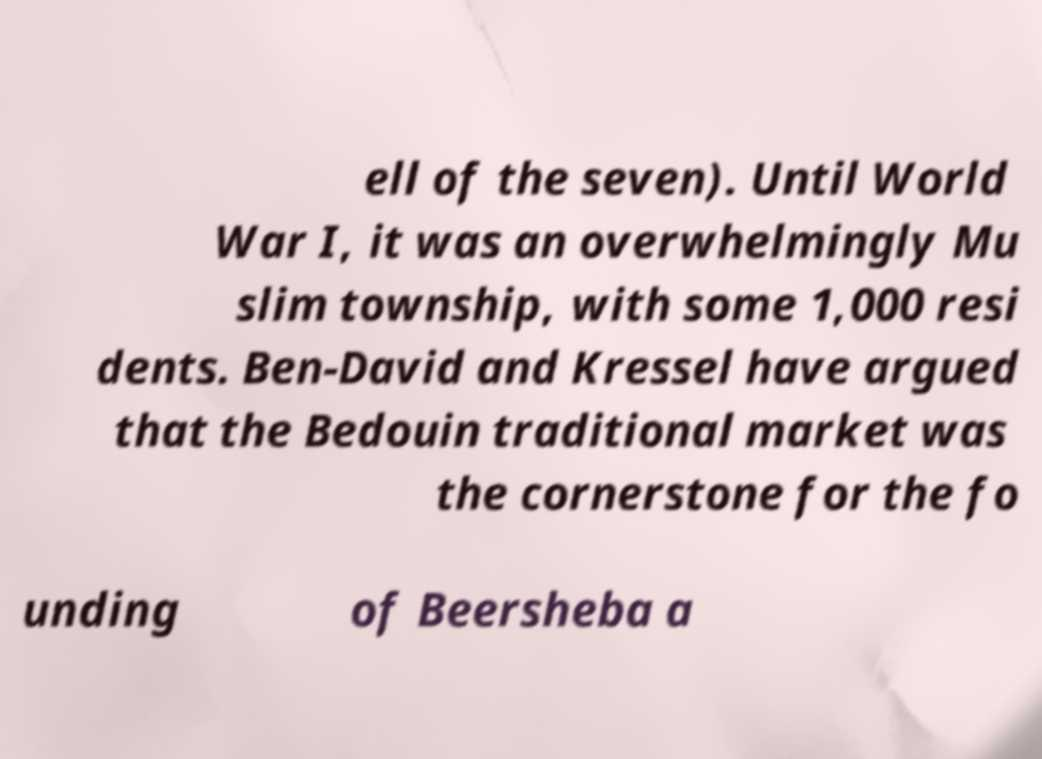I need the written content from this picture converted into text. Can you do that? ell of the seven). Until World War I, it was an overwhelmingly Mu slim township, with some 1,000 resi dents. Ben-David and Kressel have argued that the Bedouin traditional market was the cornerstone for the fo unding of Beersheba a 